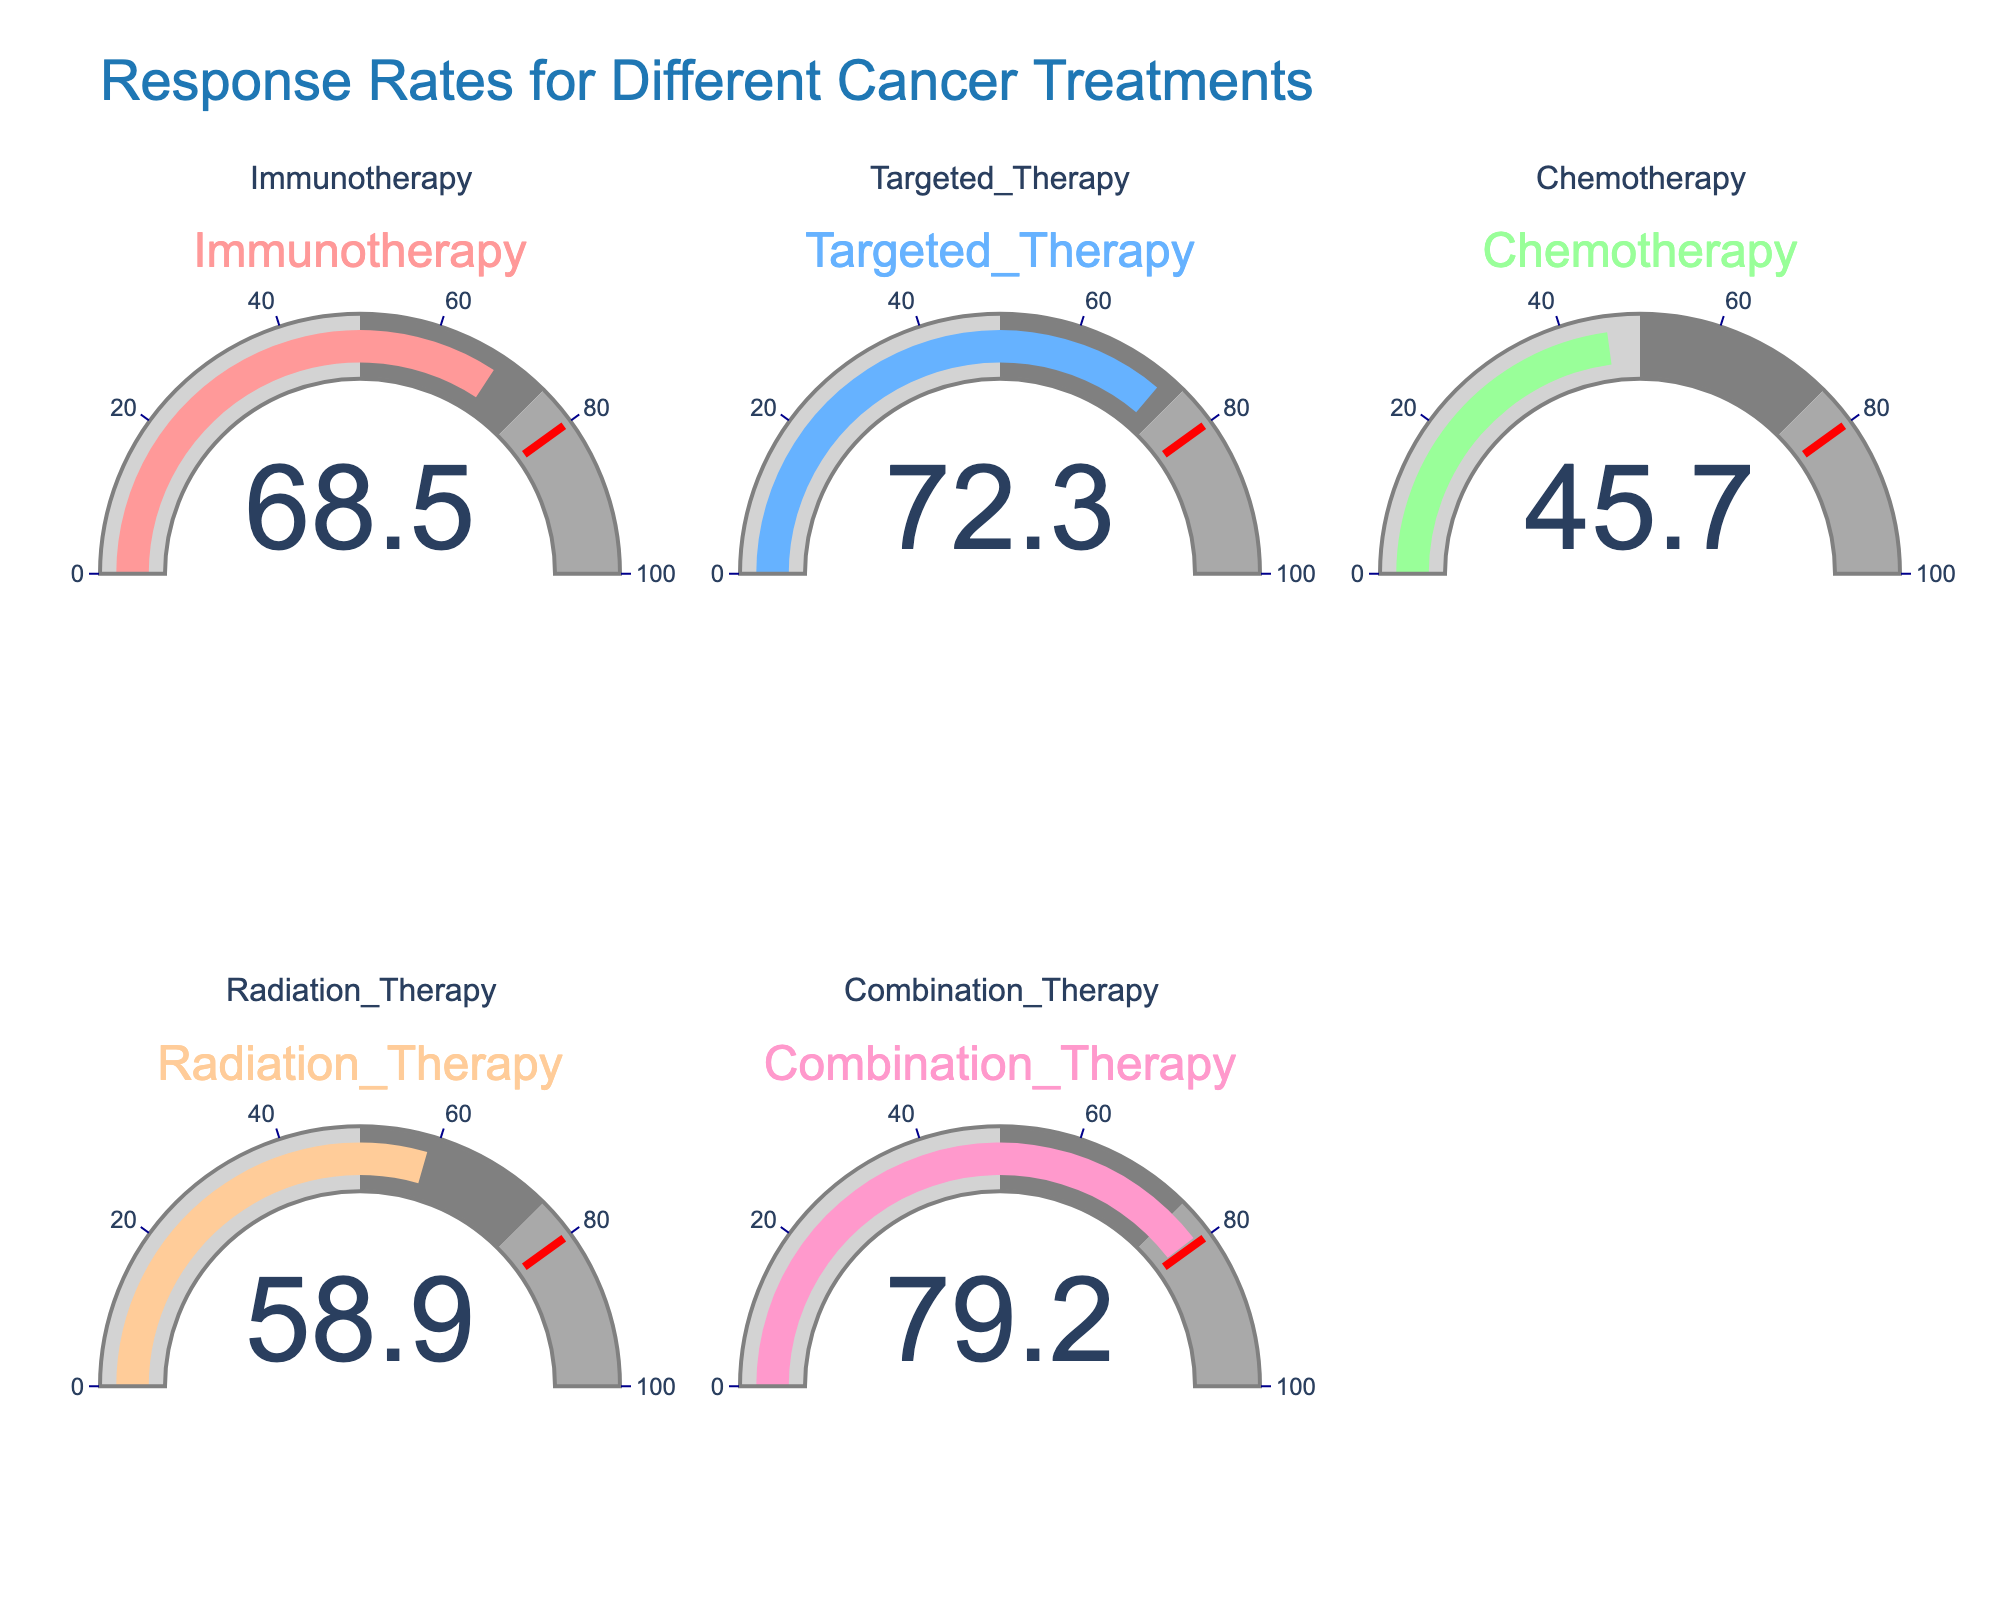What is the response rate for Immunotherapy? The gauge for Immunotherapy shows a response rate of 68.5%.
Answer: 68.5% What treatment has the highest response rate? The gauge for Combination Therapy shows the highest response rate of 79.2%.
Answer: Combination Therapy How much higher is the response rate for Targeted Therapy than for Chemotherapy? The response rate for Targeted Therapy is 72.3%, and for Chemotherapy, it is 45.7%. The difference is 72.3% - 45.7% = 26.6%.
Answer: 26.6% Which treatments have a response rate above 50%? Reading the gauges, the treatments with response rates above 50% are Immunotherapy, Targeted Therapy, Radiation Therapy, and Combination Therapy.
Answer: Immunotherapy, Targeted Therapy, Radiation Therapy, Combination Therapy Is the response rate for Chemotherapy below 50%? The gauge for Chemotherapy shows a response rate of 45.7%, which is below 50%.
Answer: Yes What is the average response rate across all treatments? The response rates are Immunotherapy (68.5%), Targeted Therapy (72.3%), Chemotherapy (45.7%), Radiation Therapy (58.9%), and Combination Therapy (79.2%). The average is (68.5 + 72.3 + 45.7 + 58.9 + 79.2) / 5 = 64.92%.
Answer: 64.92% Which treatments have a response rate that falls in the gray segment of their gauge (50-75%)? The treatments within the gray segment are Immunotherapy (68.5%), Targeted Therapy (72.3%), and Radiation Therapy (58.9%).
Answer: Immunotherapy, Targeted Therapy, Radiation Therapy By how much does Radiation Therapy's response rate fall short of reaching the threshold of 80%? The response rate for Radiation Therapy is 58.9%. The difference from 80% is 80% - 58.9% = 21.1%.
Answer: 21.1% What is the range of response rates for the treatments? The lowest response rate is for Chemotherapy (45.7%) and the highest is for Combination Therapy (79.2%). The range is 79.2% - 45.7% = 33.5%.
Answer: 33.5% 